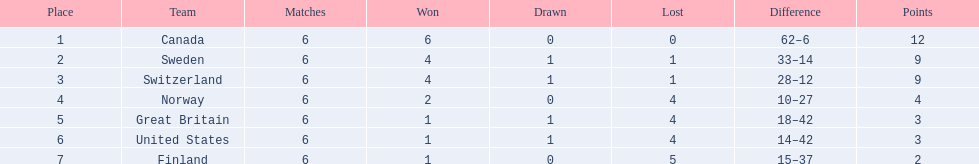Which couple of countries are being mentioned? Switzerland, Great Britain. What were the point sums for each of these countries? 9, 3. From these point sums, which is more advantageous? 9. Which country secured this point sum? Switzerland. 